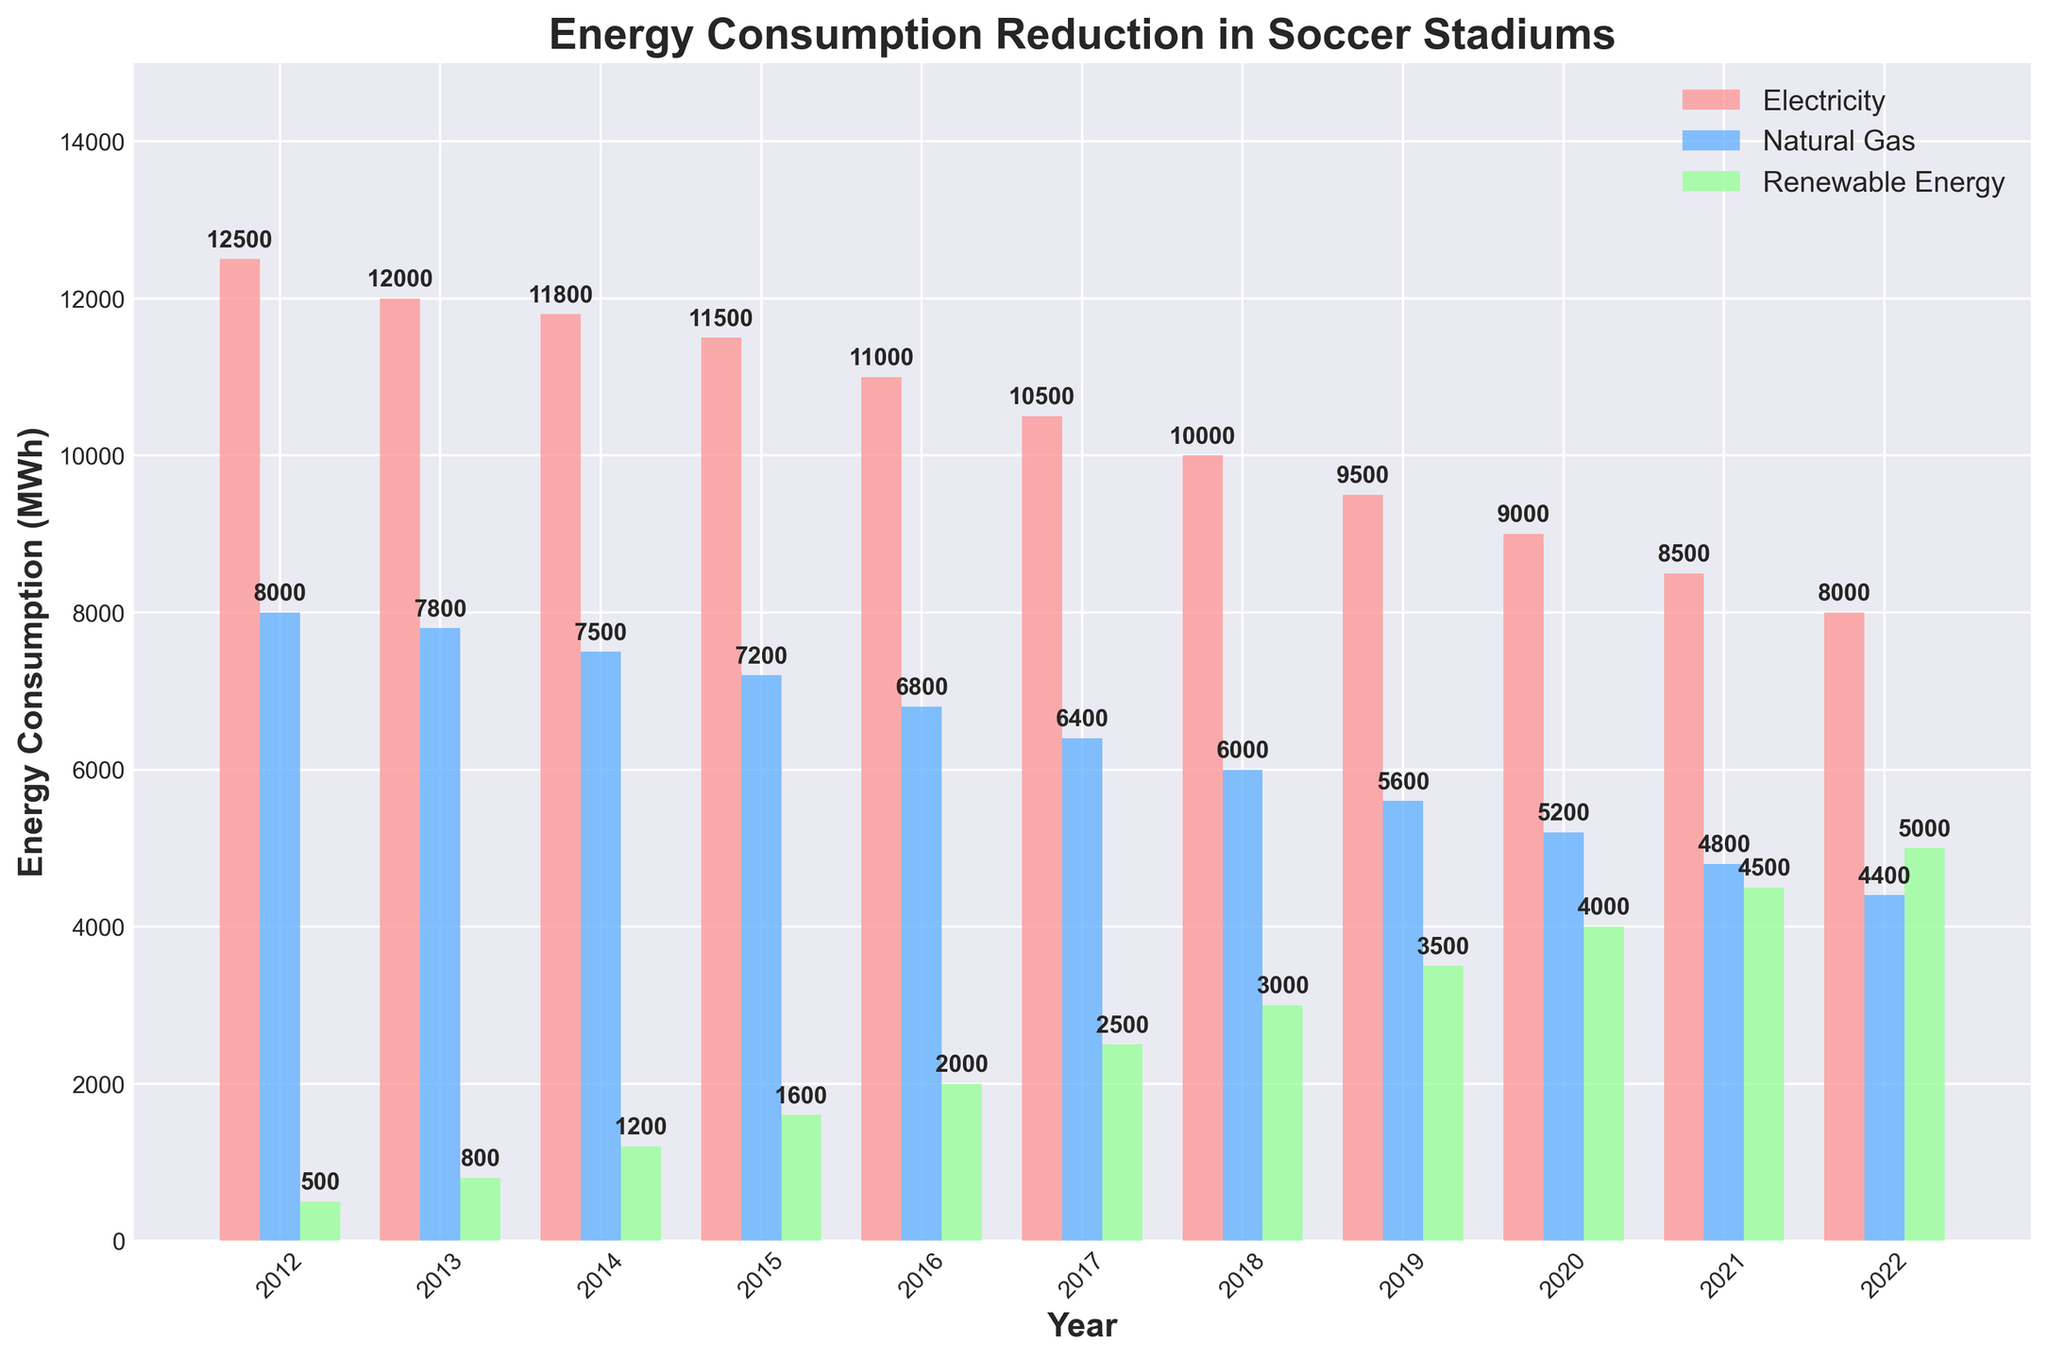What is the overall trend in electricity consumption from 2012 to 2022? From the figure, we observe that the height of the red bars (electricity consumption) decreases gradually from 2012 to 2022, indicating a downward trend in electricity consumption over the years.
Answer: Decreasing Which year had the highest utilization of renewable energy? By visually examining the green bars corresponding to renewable energy consumption, we can see that the tallest green bar is in the year 2022.
Answer: 2022 How much more electricity was consumed than natural gas in 2015? Refer to the heights of the bars for electricity (red) and natural gas (blue) in the year 2015. The electricity consumption is 11,500 MWh, and the natural gas consumption is 7,200 MWh. The difference is 11,500 - 7,200 = 4,300 MWh.
Answer: 4,300 MWh In which year did renewable energy consumption surpass natural gas consumption? Compare the bars for renewable energy (green) and natural gas (blue) across the years. In 2022, the green bar is taller than the blue bar for the first time.
Answer: 2022 What is the total energy consumption in 2020 combining electricity, natural gas, and renewable energy? Sum the heights of all three bars (red, blue, and green) for the year 2020: 9,000 (electricity) + 5,200 (natural gas) + 4,000 (renewable energy) = 18,200 MWh.
Answer: 18,200 MWh How did the ratio of renewable energy to total energy consumption change from 2012 to 2022? In 2012, renewable energy was 500 MWh, and the total energy consumption was 12,500 (electricity) + 8,000 (natural gas) + 500 (renewable) = 21,000 MWh. The ratio in 2012 is 500/21,000 ≈ 0.0238. In 2022, renewable energy is 5,000 MWh, and the total energy consumption is 8,000 (electricity) + 4,400 (natural gas) + 5,000 (renewable) = 17,400 MWh. The ratio in 2022 is 5,000/17,400 ≈ 0.2874.
Answer: Increased Which energy source saw the largest absolute reduction from 2012 to 2022? Calculate the difference in consumption for each energy source between 2012 and 2022. Electricity: 12,500 - 8,000 = 4,500 MWh, Natural Gas: 8,000 - 4,400 = 3,600 MWh, Renewable: 5,000 - 500 = 4,500 MWh. Both electricity and renewable energy saw the largest absolute reduction of 4,500 MWh.
Answer: Electricity and Renewable What is the average annual reduction in natural gas consumption over the decade? Find the change in natural gas consumption from 2012 to 2022 and divide by 10 (the number of years). Natural Gas reduction: 8,000 - 4,400 = 3,600 MWh. Average annual reduction: 3,600 / 10 = 360 MWh per year.
Answer: 360 MWh per year Which two years had the same amount of renewable energy consumption? Identify the years where the green bars are the same height: 2018 and 2019 both show renewable energy consumption of 3,000 MWh.
Answer: 2018 and 2019 